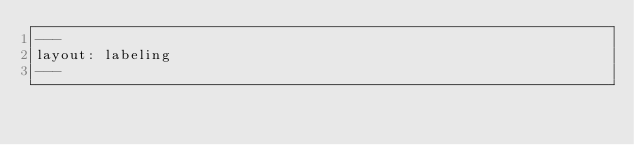Convert code to text. <code><loc_0><loc_0><loc_500><loc_500><_HTML_>---
layout: labeling
---
</code> 